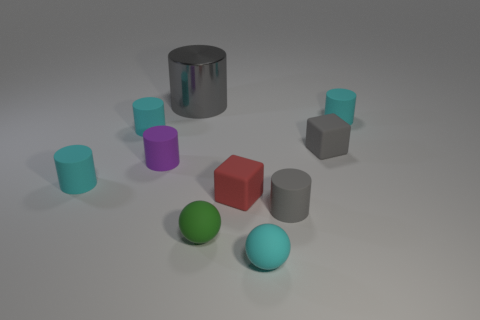Subtract all blue blocks. How many cyan cylinders are left? 3 Subtract all gray cylinders. How many cylinders are left? 4 Subtract all purple cylinders. How many cylinders are left? 5 Subtract all green cylinders. Subtract all red cubes. How many cylinders are left? 6 Subtract all cubes. How many objects are left? 8 Subtract all green rubber balls. Subtract all big yellow metallic cylinders. How many objects are left? 9 Add 2 large shiny cylinders. How many large shiny cylinders are left? 3 Add 2 red metal spheres. How many red metal spheres exist? 2 Subtract 1 green spheres. How many objects are left? 9 